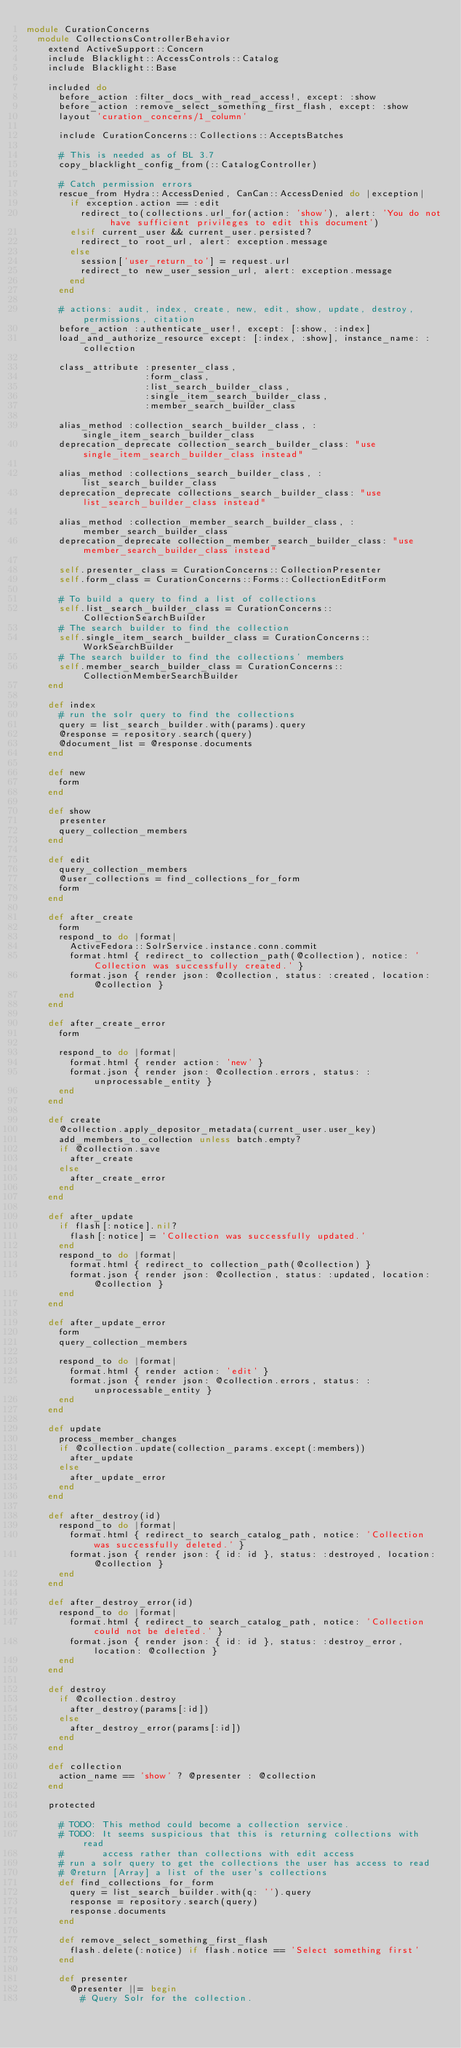Convert code to text. <code><loc_0><loc_0><loc_500><loc_500><_Ruby_>module CurationConcerns
  module CollectionsControllerBehavior
    extend ActiveSupport::Concern
    include Blacklight::AccessControls::Catalog
    include Blacklight::Base

    included do
      before_action :filter_docs_with_read_access!, except: :show
      before_action :remove_select_something_first_flash, except: :show
      layout 'curation_concerns/1_column'

      include CurationConcerns::Collections::AcceptsBatches

      # This is needed as of BL 3.7
      copy_blacklight_config_from(::CatalogController)

      # Catch permission errors
      rescue_from Hydra::AccessDenied, CanCan::AccessDenied do |exception|
        if exception.action == :edit
          redirect_to(collections.url_for(action: 'show'), alert: 'You do not have sufficient privileges to edit this document')
        elsif current_user && current_user.persisted?
          redirect_to root_url, alert: exception.message
        else
          session['user_return_to'] = request.url
          redirect_to new_user_session_url, alert: exception.message
        end
      end

      # actions: audit, index, create, new, edit, show, update, destroy, permissions, citation
      before_action :authenticate_user!, except: [:show, :index]
      load_and_authorize_resource except: [:index, :show], instance_name: :collection

      class_attribute :presenter_class,
                      :form_class,
                      :list_search_builder_class,
                      :single_item_search_builder_class,
                      :member_search_builder_class

      alias_method :collection_search_builder_class, :single_item_search_builder_class
      deprecation_deprecate collection_search_builder_class: "use single_item_search_builder_class instead"

      alias_method :collections_search_builder_class, :list_search_builder_class
      deprecation_deprecate collections_search_builder_class: "use list_search_builder_class instead"

      alias_method :collection_member_search_builder_class, :member_search_builder_class
      deprecation_deprecate collection_member_search_builder_class: "use member_search_builder_class instead"

      self.presenter_class = CurationConcerns::CollectionPresenter
      self.form_class = CurationConcerns::Forms::CollectionEditForm

      # To build a query to find a list of collections
      self.list_search_builder_class = CurationConcerns::CollectionSearchBuilder
      # The search builder to find the collection
      self.single_item_search_builder_class = CurationConcerns::WorkSearchBuilder
      # The search builder to find the collections' members
      self.member_search_builder_class = CurationConcerns::CollectionMemberSearchBuilder
    end

    def index
      # run the solr query to find the collections
      query = list_search_builder.with(params).query
      @response = repository.search(query)
      @document_list = @response.documents
    end

    def new
      form
    end

    def show
      presenter
      query_collection_members
    end

    def edit
      query_collection_members
      @user_collections = find_collections_for_form
      form
    end

    def after_create
      form
      respond_to do |format|
        ActiveFedora::SolrService.instance.conn.commit
        format.html { redirect_to collection_path(@collection), notice: 'Collection was successfully created.' }
        format.json { render json: @collection, status: :created, location: @collection }
      end
    end

    def after_create_error
      form

      respond_to do |format|
        format.html { render action: 'new' }
        format.json { render json: @collection.errors, status: :unprocessable_entity }
      end
    end

    def create
      @collection.apply_depositor_metadata(current_user.user_key)
      add_members_to_collection unless batch.empty?
      if @collection.save
        after_create
      else
        after_create_error
      end
    end

    def after_update
      if flash[:notice].nil?
        flash[:notice] = 'Collection was successfully updated.'
      end
      respond_to do |format|
        format.html { redirect_to collection_path(@collection) }
        format.json { render json: @collection, status: :updated, location: @collection }
      end
    end

    def after_update_error
      form
      query_collection_members

      respond_to do |format|
        format.html { render action: 'edit' }
        format.json { render json: @collection.errors, status: :unprocessable_entity }
      end
    end

    def update
      process_member_changes
      if @collection.update(collection_params.except(:members))
        after_update
      else
        after_update_error
      end
    end

    def after_destroy(id)
      respond_to do |format|
        format.html { redirect_to search_catalog_path, notice: 'Collection was successfully deleted.' }
        format.json { render json: { id: id }, status: :destroyed, location: @collection }
      end
    end

    def after_destroy_error(id)
      respond_to do |format|
        format.html { redirect_to search_catalog_path, notice: 'Collection could not be deleted.' }
        format.json { render json: { id: id }, status: :destroy_error, location: @collection }
      end
    end

    def destroy
      if @collection.destroy
        after_destroy(params[:id])
      else
        after_destroy_error(params[:id])
      end
    end

    def collection
      action_name == 'show' ? @presenter : @collection
    end

    protected

      # TODO: This method could become a collection service.
      # TODO: It seems suspicious that this is returning collections with read
      #       access rather than collections with edit access
      # run a solr query to get the collections the user has access to read
      # @return [Array] a list of the user's collections
      def find_collections_for_form
        query = list_search_builder.with(q: '').query
        response = repository.search(query)
        response.documents
      end

      def remove_select_something_first_flash
        flash.delete(:notice) if flash.notice == 'Select something first'
      end

      def presenter
        @presenter ||= begin
          # Query Solr for the collection.</code> 